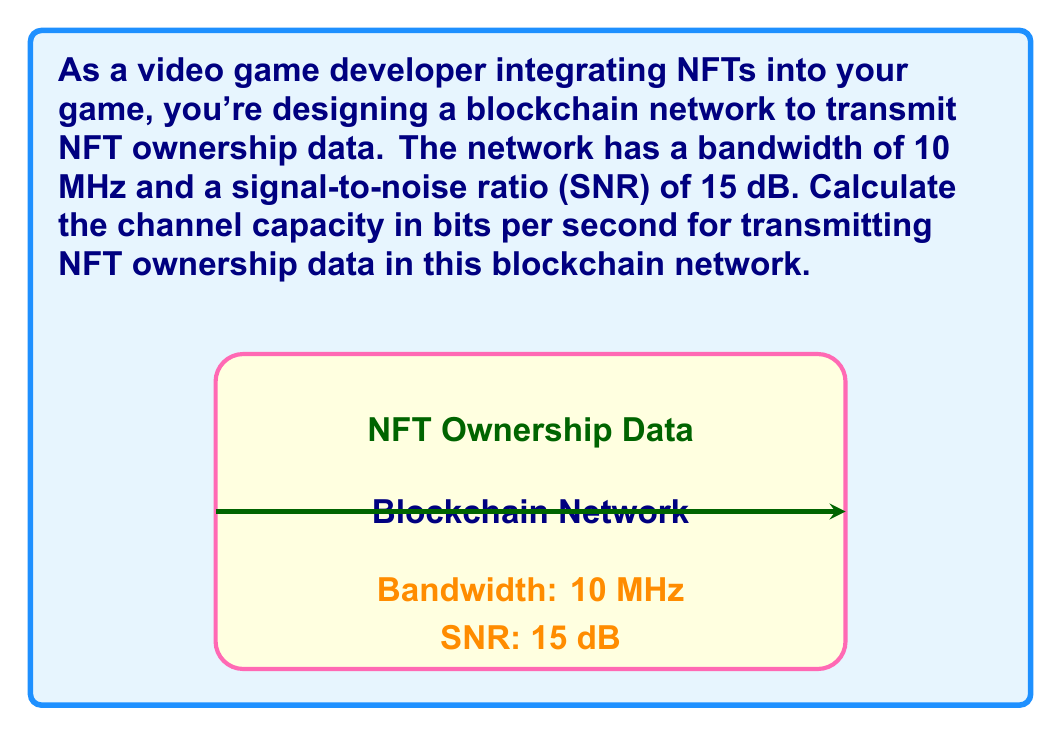Teach me how to tackle this problem. To solve this problem, we'll use the Shannon-Hartley theorem, which gives the channel capacity for a communication channel with Gaussian noise. The formula is:

$$C = B \log_2(1 + SNR)$$

Where:
$C$ is the channel capacity in bits per second
$B$ is the bandwidth in Hz
$SNR$ is the signal-to-noise ratio (linear, not dB)

Step 1: Convert the given bandwidth to Hz
$B = 10 \text{ MHz} = 10 \times 10^6 \text{ Hz}$

Step 2: Convert SNR from dB to linear scale
$SNR_{linear} = 10^{(SNR_{dB} / 10)} = 10^{(15 / 10)} = 10^{1.5} \approx 31.6228$

Step 3: Apply the Shannon-Hartley theorem
$$\begin{align}
C &= B \log_2(1 + SNR) \\
&= (10 \times 10^6) \log_2(1 + 31.6228) \\
&\approx (10 \times 10^6) \log_2(32.6228) \\
&\approx (10 \times 10^6) \times 5.0279 \\
&\approx 50,279,000 \text{ bits per second}
\end{align}$$

Therefore, the channel capacity for transmitting NFT ownership data in this blockchain network is approximately 50.279 Mbps.
Answer: 50.279 Mbps 